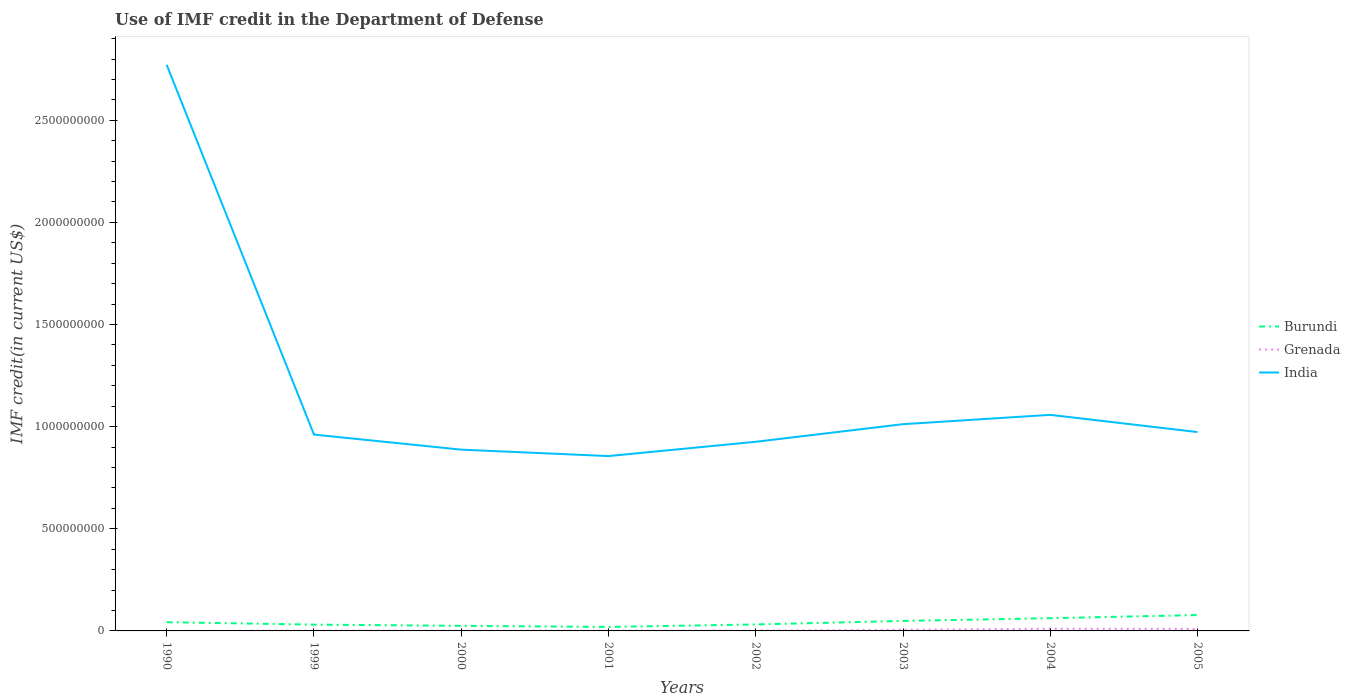Is the number of lines equal to the number of legend labels?
Keep it short and to the point. Yes. Across all years, what is the maximum IMF credit in the Department of Defense in Burundi?
Provide a short and direct response. 1.96e+07. What is the total IMF credit in the Department of Defense in Grenada in the graph?
Provide a succinct answer. -9.50e+04. What is the difference between the highest and the second highest IMF credit in the Department of Defense in Grenada?
Your answer should be very brief. 1.05e+07. What is the difference between the highest and the lowest IMF credit in the Department of Defense in Burundi?
Keep it short and to the point. 4. What is the difference between two consecutive major ticks on the Y-axis?
Your answer should be very brief. 5.00e+08. Does the graph contain grids?
Your answer should be very brief. No. How are the legend labels stacked?
Ensure brevity in your answer.  Vertical. What is the title of the graph?
Your answer should be compact. Use of IMF credit in the Department of Defense. What is the label or title of the X-axis?
Give a very brief answer. Years. What is the label or title of the Y-axis?
Give a very brief answer. IMF credit(in current US$). What is the IMF credit(in current US$) of Burundi in 1990?
Provide a succinct answer. 4.26e+07. What is the IMF credit(in current US$) of Grenada in 1990?
Offer a terse response. 1.10e+04. What is the IMF credit(in current US$) in India in 1990?
Your answer should be very brief. 2.77e+09. What is the IMF credit(in current US$) in Burundi in 1999?
Your answer should be compact. 3.09e+07. What is the IMF credit(in current US$) of Grenada in 1999?
Offer a very short reply. 1.28e+06. What is the IMF credit(in current US$) in India in 1999?
Your answer should be compact. 9.61e+08. What is the IMF credit(in current US$) of Burundi in 2000?
Keep it short and to the point. 2.48e+07. What is the IMF credit(in current US$) of Grenada in 2000?
Your answer should be very brief. 1.21e+06. What is the IMF credit(in current US$) of India in 2000?
Provide a succinct answer. 8.88e+08. What is the IMF credit(in current US$) in Burundi in 2001?
Give a very brief answer. 1.96e+07. What is the IMF credit(in current US$) in Grenada in 2001?
Provide a succinct answer. 1.17e+06. What is the IMF credit(in current US$) in India in 2001?
Ensure brevity in your answer.  8.56e+08. What is the IMF credit(in current US$) in Burundi in 2002?
Keep it short and to the point. 3.17e+07. What is the IMF credit(in current US$) of Grenada in 2002?
Ensure brevity in your answer.  1.26e+06. What is the IMF credit(in current US$) of India in 2002?
Ensure brevity in your answer.  9.26e+08. What is the IMF credit(in current US$) of Burundi in 2003?
Offer a very short reply. 4.90e+07. What is the IMF credit(in current US$) in Grenada in 2003?
Provide a succinct answer. 5.74e+06. What is the IMF credit(in current US$) of India in 2003?
Provide a short and direct response. 1.01e+09. What is the IMF credit(in current US$) of Burundi in 2004?
Your response must be concise. 6.23e+07. What is the IMF credit(in current US$) in Grenada in 2004?
Make the answer very short. 1.05e+07. What is the IMF credit(in current US$) of India in 2004?
Keep it short and to the point. 1.06e+09. What is the IMF credit(in current US$) of Burundi in 2005?
Provide a succinct answer. 7.77e+07. What is the IMF credit(in current US$) in Grenada in 2005?
Provide a succinct answer. 9.70e+06. What is the IMF credit(in current US$) of India in 2005?
Your answer should be very brief. 9.74e+08. Across all years, what is the maximum IMF credit(in current US$) in Burundi?
Your answer should be very brief. 7.77e+07. Across all years, what is the maximum IMF credit(in current US$) of Grenada?
Give a very brief answer. 1.05e+07. Across all years, what is the maximum IMF credit(in current US$) in India?
Provide a succinct answer. 2.77e+09. Across all years, what is the minimum IMF credit(in current US$) of Burundi?
Make the answer very short. 1.96e+07. Across all years, what is the minimum IMF credit(in current US$) of Grenada?
Offer a very short reply. 1.10e+04. Across all years, what is the minimum IMF credit(in current US$) of India?
Provide a short and direct response. 8.56e+08. What is the total IMF credit(in current US$) in Burundi in the graph?
Your answer should be compact. 3.39e+08. What is the total IMF credit(in current US$) of Grenada in the graph?
Offer a terse response. 3.09e+07. What is the total IMF credit(in current US$) of India in the graph?
Offer a very short reply. 9.45e+09. What is the difference between the IMF credit(in current US$) in Burundi in 1990 and that in 1999?
Give a very brief answer. 1.17e+07. What is the difference between the IMF credit(in current US$) in Grenada in 1990 and that in 1999?
Make the answer very short. -1.26e+06. What is the difference between the IMF credit(in current US$) of India in 1990 and that in 1999?
Your answer should be very brief. 1.81e+09. What is the difference between the IMF credit(in current US$) in Burundi in 1990 and that in 2000?
Offer a very short reply. 1.78e+07. What is the difference between the IMF credit(in current US$) in Grenada in 1990 and that in 2000?
Your answer should be very brief. -1.20e+06. What is the difference between the IMF credit(in current US$) of India in 1990 and that in 2000?
Provide a succinct answer. 1.88e+09. What is the difference between the IMF credit(in current US$) in Burundi in 1990 and that in 2001?
Provide a succinct answer. 2.30e+07. What is the difference between the IMF credit(in current US$) of Grenada in 1990 and that in 2001?
Give a very brief answer. -1.16e+06. What is the difference between the IMF credit(in current US$) in India in 1990 and that in 2001?
Make the answer very short. 1.92e+09. What is the difference between the IMF credit(in current US$) of Burundi in 1990 and that in 2002?
Provide a succinct answer. 1.09e+07. What is the difference between the IMF credit(in current US$) of Grenada in 1990 and that in 2002?
Your answer should be very brief. -1.25e+06. What is the difference between the IMF credit(in current US$) of India in 1990 and that in 2002?
Offer a terse response. 1.85e+09. What is the difference between the IMF credit(in current US$) of Burundi in 1990 and that in 2003?
Offer a very short reply. -6.33e+06. What is the difference between the IMF credit(in current US$) of Grenada in 1990 and that in 2003?
Your answer should be very brief. -5.72e+06. What is the difference between the IMF credit(in current US$) in India in 1990 and that in 2003?
Ensure brevity in your answer.  1.76e+09. What is the difference between the IMF credit(in current US$) in Burundi in 1990 and that in 2004?
Offer a terse response. -1.96e+07. What is the difference between the IMF credit(in current US$) in Grenada in 1990 and that in 2004?
Provide a short and direct response. -1.05e+07. What is the difference between the IMF credit(in current US$) of India in 1990 and that in 2004?
Ensure brevity in your answer.  1.71e+09. What is the difference between the IMF credit(in current US$) in Burundi in 1990 and that in 2005?
Your response must be concise. -3.51e+07. What is the difference between the IMF credit(in current US$) in Grenada in 1990 and that in 2005?
Make the answer very short. -9.69e+06. What is the difference between the IMF credit(in current US$) in India in 1990 and that in 2005?
Make the answer very short. 1.80e+09. What is the difference between the IMF credit(in current US$) of Burundi in 1999 and that in 2000?
Offer a very short reply. 6.05e+06. What is the difference between the IMF credit(in current US$) of Grenada in 1999 and that in 2000?
Offer a terse response. 6.40e+04. What is the difference between the IMF credit(in current US$) in India in 1999 and that in 2000?
Offer a very short reply. 7.38e+07. What is the difference between the IMF credit(in current US$) in Burundi in 1999 and that in 2001?
Give a very brief answer. 1.13e+07. What is the difference between the IMF credit(in current US$) in Grenada in 1999 and that in 2001?
Keep it short and to the point. 1.07e+05. What is the difference between the IMF credit(in current US$) in India in 1999 and that in 2001?
Provide a short and direct response. 1.05e+08. What is the difference between the IMF credit(in current US$) in Burundi in 1999 and that in 2002?
Offer a terse response. -8.04e+05. What is the difference between the IMF credit(in current US$) of Grenada in 1999 and that in 2002?
Provide a succinct answer. 1.20e+04. What is the difference between the IMF credit(in current US$) in India in 1999 and that in 2002?
Your answer should be compact. 3.53e+07. What is the difference between the IMF credit(in current US$) of Burundi in 1999 and that in 2003?
Offer a terse response. -1.81e+07. What is the difference between the IMF credit(in current US$) in Grenada in 1999 and that in 2003?
Keep it short and to the point. -4.46e+06. What is the difference between the IMF credit(in current US$) of India in 1999 and that in 2003?
Keep it short and to the point. -5.09e+07. What is the difference between the IMF credit(in current US$) of Burundi in 1999 and that in 2004?
Provide a short and direct response. -3.14e+07. What is the difference between the IMF credit(in current US$) of Grenada in 1999 and that in 2004?
Keep it short and to the point. -9.26e+06. What is the difference between the IMF credit(in current US$) in India in 1999 and that in 2004?
Provide a succinct answer. -9.65e+07. What is the difference between the IMF credit(in current US$) in Burundi in 1999 and that in 2005?
Provide a short and direct response. -4.68e+07. What is the difference between the IMF credit(in current US$) in Grenada in 1999 and that in 2005?
Keep it short and to the point. -8.42e+06. What is the difference between the IMF credit(in current US$) of India in 1999 and that in 2005?
Offer a terse response. -1.22e+07. What is the difference between the IMF credit(in current US$) in Burundi in 2000 and that in 2001?
Provide a short and direct response. 5.21e+06. What is the difference between the IMF credit(in current US$) in Grenada in 2000 and that in 2001?
Provide a short and direct response. 4.30e+04. What is the difference between the IMF credit(in current US$) of India in 2000 and that in 2001?
Give a very brief answer. 3.15e+07. What is the difference between the IMF credit(in current US$) in Burundi in 2000 and that in 2002?
Keep it short and to the point. -6.86e+06. What is the difference between the IMF credit(in current US$) of Grenada in 2000 and that in 2002?
Your response must be concise. -5.20e+04. What is the difference between the IMF credit(in current US$) in India in 2000 and that in 2002?
Make the answer very short. -3.86e+07. What is the difference between the IMF credit(in current US$) of Burundi in 2000 and that in 2003?
Ensure brevity in your answer.  -2.41e+07. What is the difference between the IMF credit(in current US$) of Grenada in 2000 and that in 2003?
Give a very brief answer. -4.52e+06. What is the difference between the IMF credit(in current US$) in India in 2000 and that in 2003?
Make the answer very short. -1.25e+08. What is the difference between the IMF credit(in current US$) of Burundi in 2000 and that in 2004?
Keep it short and to the point. -3.74e+07. What is the difference between the IMF credit(in current US$) in Grenada in 2000 and that in 2004?
Keep it short and to the point. -9.32e+06. What is the difference between the IMF credit(in current US$) in India in 2000 and that in 2004?
Ensure brevity in your answer.  -1.70e+08. What is the difference between the IMF credit(in current US$) of Burundi in 2000 and that in 2005?
Offer a terse response. -5.29e+07. What is the difference between the IMF credit(in current US$) in Grenada in 2000 and that in 2005?
Make the answer very short. -8.48e+06. What is the difference between the IMF credit(in current US$) of India in 2000 and that in 2005?
Keep it short and to the point. -8.61e+07. What is the difference between the IMF credit(in current US$) in Burundi in 2001 and that in 2002?
Provide a succinct answer. -1.21e+07. What is the difference between the IMF credit(in current US$) of Grenada in 2001 and that in 2002?
Your answer should be compact. -9.50e+04. What is the difference between the IMF credit(in current US$) in India in 2001 and that in 2002?
Keep it short and to the point. -7.00e+07. What is the difference between the IMF credit(in current US$) in Burundi in 2001 and that in 2003?
Offer a very short reply. -2.93e+07. What is the difference between the IMF credit(in current US$) of Grenada in 2001 and that in 2003?
Give a very brief answer. -4.57e+06. What is the difference between the IMF credit(in current US$) of India in 2001 and that in 2003?
Ensure brevity in your answer.  -1.56e+08. What is the difference between the IMF credit(in current US$) in Burundi in 2001 and that in 2004?
Make the answer very short. -4.26e+07. What is the difference between the IMF credit(in current US$) of Grenada in 2001 and that in 2004?
Your response must be concise. -9.37e+06. What is the difference between the IMF credit(in current US$) of India in 2001 and that in 2004?
Your answer should be compact. -2.02e+08. What is the difference between the IMF credit(in current US$) of Burundi in 2001 and that in 2005?
Your answer should be very brief. -5.81e+07. What is the difference between the IMF credit(in current US$) of Grenada in 2001 and that in 2005?
Your response must be concise. -8.53e+06. What is the difference between the IMF credit(in current US$) in India in 2001 and that in 2005?
Your response must be concise. -1.18e+08. What is the difference between the IMF credit(in current US$) of Burundi in 2002 and that in 2003?
Keep it short and to the point. -1.73e+07. What is the difference between the IMF credit(in current US$) of Grenada in 2002 and that in 2003?
Offer a terse response. -4.47e+06. What is the difference between the IMF credit(in current US$) of India in 2002 and that in 2003?
Offer a terse response. -8.61e+07. What is the difference between the IMF credit(in current US$) of Burundi in 2002 and that in 2004?
Your answer should be compact. -3.06e+07. What is the difference between the IMF credit(in current US$) in Grenada in 2002 and that in 2004?
Your answer should be compact. -9.27e+06. What is the difference between the IMF credit(in current US$) of India in 2002 and that in 2004?
Keep it short and to the point. -1.32e+08. What is the difference between the IMF credit(in current US$) of Burundi in 2002 and that in 2005?
Offer a very short reply. -4.60e+07. What is the difference between the IMF credit(in current US$) in Grenada in 2002 and that in 2005?
Your answer should be very brief. -8.43e+06. What is the difference between the IMF credit(in current US$) of India in 2002 and that in 2005?
Your answer should be very brief. -4.75e+07. What is the difference between the IMF credit(in current US$) in Burundi in 2003 and that in 2004?
Give a very brief answer. -1.33e+07. What is the difference between the IMF credit(in current US$) in Grenada in 2003 and that in 2004?
Your answer should be compact. -4.80e+06. What is the difference between the IMF credit(in current US$) in India in 2003 and that in 2004?
Your answer should be very brief. -4.57e+07. What is the difference between the IMF credit(in current US$) in Burundi in 2003 and that in 2005?
Give a very brief answer. -2.88e+07. What is the difference between the IMF credit(in current US$) in Grenada in 2003 and that in 2005?
Offer a terse response. -3.96e+06. What is the difference between the IMF credit(in current US$) of India in 2003 and that in 2005?
Keep it short and to the point. 3.86e+07. What is the difference between the IMF credit(in current US$) of Burundi in 2004 and that in 2005?
Provide a short and direct response. -1.55e+07. What is the difference between the IMF credit(in current US$) of Grenada in 2004 and that in 2005?
Your answer should be very brief. 8.40e+05. What is the difference between the IMF credit(in current US$) in India in 2004 and that in 2005?
Ensure brevity in your answer.  8.43e+07. What is the difference between the IMF credit(in current US$) of Burundi in 1990 and the IMF credit(in current US$) of Grenada in 1999?
Your answer should be very brief. 4.13e+07. What is the difference between the IMF credit(in current US$) of Burundi in 1990 and the IMF credit(in current US$) of India in 1999?
Keep it short and to the point. -9.19e+08. What is the difference between the IMF credit(in current US$) of Grenada in 1990 and the IMF credit(in current US$) of India in 1999?
Keep it short and to the point. -9.61e+08. What is the difference between the IMF credit(in current US$) in Burundi in 1990 and the IMF credit(in current US$) in Grenada in 2000?
Give a very brief answer. 4.14e+07. What is the difference between the IMF credit(in current US$) in Burundi in 1990 and the IMF credit(in current US$) in India in 2000?
Your answer should be compact. -8.45e+08. What is the difference between the IMF credit(in current US$) in Grenada in 1990 and the IMF credit(in current US$) in India in 2000?
Your answer should be compact. -8.87e+08. What is the difference between the IMF credit(in current US$) in Burundi in 1990 and the IMF credit(in current US$) in Grenada in 2001?
Keep it short and to the point. 4.15e+07. What is the difference between the IMF credit(in current US$) in Burundi in 1990 and the IMF credit(in current US$) in India in 2001?
Your answer should be compact. -8.13e+08. What is the difference between the IMF credit(in current US$) of Grenada in 1990 and the IMF credit(in current US$) of India in 2001?
Ensure brevity in your answer.  -8.56e+08. What is the difference between the IMF credit(in current US$) in Burundi in 1990 and the IMF credit(in current US$) in Grenada in 2002?
Provide a succinct answer. 4.14e+07. What is the difference between the IMF credit(in current US$) of Burundi in 1990 and the IMF credit(in current US$) of India in 2002?
Your answer should be compact. -8.83e+08. What is the difference between the IMF credit(in current US$) of Grenada in 1990 and the IMF credit(in current US$) of India in 2002?
Your response must be concise. -9.26e+08. What is the difference between the IMF credit(in current US$) of Burundi in 1990 and the IMF credit(in current US$) of Grenada in 2003?
Make the answer very short. 3.69e+07. What is the difference between the IMF credit(in current US$) in Burundi in 1990 and the IMF credit(in current US$) in India in 2003?
Your response must be concise. -9.70e+08. What is the difference between the IMF credit(in current US$) in Grenada in 1990 and the IMF credit(in current US$) in India in 2003?
Provide a succinct answer. -1.01e+09. What is the difference between the IMF credit(in current US$) of Burundi in 1990 and the IMF credit(in current US$) of Grenada in 2004?
Provide a short and direct response. 3.21e+07. What is the difference between the IMF credit(in current US$) of Burundi in 1990 and the IMF credit(in current US$) of India in 2004?
Ensure brevity in your answer.  -1.02e+09. What is the difference between the IMF credit(in current US$) in Grenada in 1990 and the IMF credit(in current US$) in India in 2004?
Provide a short and direct response. -1.06e+09. What is the difference between the IMF credit(in current US$) of Burundi in 1990 and the IMF credit(in current US$) of Grenada in 2005?
Your answer should be compact. 3.29e+07. What is the difference between the IMF credit(in current US$) of Burundi in 1990 and the IMF credit(in current US$) of India in 2005?
Make the answer very short. -9.31e+08. What is the difference between the IMF credit(in current US$) of Grenada in 1990 and the IMF credit(in current US$) of India in 2005?
Your response must be concise. -9.74e+08. What is the difference between the IMF credit(in current US$) of Burundi in 1999 and the IMF credit(in current US$) of Grenada in 2000?
Your answer should be compact. 2.97e+07. What is the difference between the IMF credit(in current US$) of Burundi in 1999 and the IMF credit(in current US$) of India in 2000?
Your answer should be compact. -8.57e+08. What is the difference between the IMF credit(in current US$) in Grenada in 1999 and the IMF credit(in current US$) in India in 2000?
Give a very brief answer. -8.86e+08. What is the difference between the IMF credit(in current US$) of Burundi in 1999 and the IMF credit(in current US$) of Grenada in 2001?
Your answer should be compact. 2.97e+07. What is the difference between the IMF credit(in current US$) in Burundi in 1999 and the IMF credit(in current US$) in India in 2001?
Offer a very short reply. -8.25e+08. What is the difference between the IMF credit(in current US$) of Grenada in 1999 and the IMF credit(in current US$) of India in 2001?
Provide a succinct answer. -8.55e+08. What is the difference between the IMF credit(in current US$) in Burundi in 1999 and the IMF credit(in current US$) in Grenada in 2002?
Your answer should be very brief. 2.96e+07. What is the difference between the IMF credit(in current US$) in Burundi in 1999 and the IMF credit(in current US$) in India in 2002?
Your answer should be compact. -8.95e+08. What is the difference between the IMF credit(in current US$) in Grenada in 1999 and the IMF credit(in current US$) in India in 2002?
Make the answer very short. -9.25e+08. What is the difference between the IMF credit(in current US$) in Burundi in 1999 and the IMF credit(in current US$) in Grenada in 2003?
Offer a terse response. 2.52e+07. What is the difference between the IMF credit(in current US$) in Burundi in 1999 and the IMF credit(in current US$) in India in 2003?
Give a very brief answer. -9.81e+08. What is the difference between the IMF credit(in current US$) in Grenada in 1999 and the IMF credit(in current US$) in India in 2003?
Offer a terse response. -1.01e+09. What is the difference between the IMF credit(in current US$) of Burundi in 1999 and the IMF credit(in current US$) of Grenada in 2004?
Provide a short and direct response. 2.04e+07. What is the difference between the IMF credit(in current US$) in Burundi in 1999 and the IMF credit(in current US$) in India in 2004?
Make the answer very short. -1.03e+09. What is the difference between the IMF credit(in current US$) of Grenada in 1999 and the IMF credit(in current US$) of India in 2004?
Provide a succinct answer. -1.06e+09. What is the difference between the IMF credit(in current US$) of Burundi in 1999 and the IMF credit(in current US$) of Grenada in 2005?
Give a very brief answer. 2.12e+07. What is the difference between the IMF credit(in current US$) of Burundi in 1999 and the IMF credit(in current US$) of India in 2005?
Keep it short and to the point. -9.43e+08. What is the difference between the IMF credit(in current US$) in Grenada in 1999 and the IMF credit(in current US$) in India in 2005?
Keep it short and to the point. -9.72e+08. What is the difference between the IMF credit(in current US$) in Burundi in 2000 and the IMF credit(in current US$) in Grenada in 2001?
Provide a succinct answer. 2.37e+07. What is the difference between the IMF credit(in current US$) of Burundi in 2000 and the IMF credit(in current US$) of India in 2001?
Your answer should be compact. -8.31e+08. What is the difference between the IMF credit(in current US$) in Grenada in 2000 and the IMF credit(in current US$) in India in 2001?
Give a very brief answer. -8.55e+08. What is the difference between the IMF credit(in current US$) of Burundi in 2000 and the IMF credit(in current US$) of Grenada in 2002?
Offer a terse response. 2.36e+07. What is the difference between the IMF credit(in current US$) in Burundi in 2000 and the IMF credit(in current US$) in India in 2002?
Give a very brief answer. -9.01e+08. What is the difference between the IMF credit(in current US$) in Grenada in 2000 and the IMF credit(in current US$) in India in 2002?
Provide a short and direct response. -9.25e+08. What is the difference between the IMF credit(in current US$) in Burundi in 2000 and the IMF credit(in current US$) in Grenada in 2003?
Give a very brief answer. 1.91e+07. What is the difference between the IMF credit(in current US$) of Burundi in 2000 and the IMF credit(in current US$) of India in 2003?
Your answer should be very brief. -9.87e+08. What is the difference between the IMF credit(in current US$) in Grenada in 2000 and the IMF credit(in current US$) in India in 2003?
Keep it short and to the point. -1.01e+09. What is the difference between the IMF credit(in current US$) in Burundi in 2000 and the IMF credit(in current US$) in Grenada in 2004?
Offer a very short reply. 1.43e+07. What is the difference between the IMF credit(in current US$) in Burundi in 2000 and the IMF credit(in current US$) in India in 2004?
Your answer should be very brief. -1.03e+09. What is the difference between the IMF credit(in current US$) of Grenada in 2000 and the IMF credit(in current US$) of India in 2004?
Your response must be concise. -1.06e+09. What is the difference between the IMF credit(in current US$) in Burundi in 2000 and the IMF credit(in current US$) in Grenada in 2005?
Give a very brief answer. 1.52e+07. What is the difference between the IMF credit(in current US$) of Burundi in 2000 and the IMF credit(in current US$) of India in 2005?
Your response must be concise. -9.49e+08. What is the difference between the IMF credit(in current US$) in Grenada in 2000 and the IMF credit(in current US$) in India in 2005?
Your response must be concise. -9.72e+08. What is the difference between the IMF credit(in current US$) in Burundi in 2001 and the IMF credit(in current US$) in Grenada in 2002?
Your answer should be very brief. 1.84e+07. What is the difference between the IMF credit(in current US$) of Burundi in 2001 and the IMF credit(in current US$) of India in 2002?
Make the answer very short. -9.06e+08. What is the difference between the IMF credit(in current US$) of Grenada in 2001 and the IMF credit(in current US$) of India in 2002?
Give a very brief answer. -9.25e+08. What is the difference between the IMF credit(in current US$) in Burundi in 2001 and the IMF credit(in current US$) in Grenada in 2003?
Provide a short and direct response. 1.39e+07. What is the difference between the IMF credit(in current US$) in Burundi in 2001 and the IMF credit(in current US$) in India in 2003?
Your answer should be compact. -9.93e+08. What is the difference between the IMF credit(in current US$) of Grenada in 2001 and the IMF credit(in current US$) of India in 2003?
Provide a short and direct response. -1.01e+09. What is the difference between the IMF credit(in current US$) of Burundi in 2001 and the IMF credit(in current US$) of Grenada in 2004?
Ensure brevity in your answer.  9.11e+06. What is the difference between the IMF credit(in current US$) in Burundi in 2001 and the IMF credit(in current US$) in India in 2004?
Make the answer very short. -1.04e+09. What is the difference between the IMF credit(in current US$) in Grenada in 2001 and the IMF credit(in current US$) in India in 2004?
Keep it short and to the point. -1.06e+09. What is the difference between the IMF credit(in current US$) in Burundi in 2001 and the IMF credit(in current US$) in Grenada in 2005?
Give a very brief answer. 9.95e+06. What is the difference between the IMF credit(in current US$) of Burundi in 2001 and the IMF credit(in current US$) of India in 2005?
Keep it short and to the point. -9.54e+08. What is the difference between the IMF credit(in current US$) of Grenada in 2001 and the IMF credit(in current US$) of India in 2005?
Your response must be concise. -9.72e+08. What is the difference between the IMF credit(in current US$) of Burundi in 2002 and the IMF credit(in current US$) of Grenada in 2003?
Your answer should be very brief. 2.60e+07. What is the difference between the IMF credit(in current US$) in Burundi in 2002 and the IMF credit(in current US$) in India in 2003?
Your response must be concise. -9.80e+08. What is the difference between the IMF credit(in current US$) of Grenada in 2002 and the IMF credit(in current US$) of India in 2003?
Ensure brevity in your answer.  -1.01e+09. What is the difference between the IMF credit(in current US$) in Burundi in 2002 and the IMF credit(in current US$) in Grenada in 2004?
Your answer should be compact. 2.12e+07. What is the difference between the IMF credit(in current US$) of Burundi in 2002 and the IMF credit(in current US$) of India in 2004?
Ensure brevity in your answer.  -1.03e+09. What is the difference between the IMF credit(in current US$) in Grenada in 2002 and the IMF credit(in current US$) in India in 2004?
Give a very brief answer. -1.06e+09. What is the difference between the IMF credit(in current US$) of Burundi in 2002 and the IMF credit(in current US$) of Grenada in 2005?
Offer a very short reply. 2.20e+07. What is the difference between the IMF credit(in current US$) in Burundi in 2002 and the IMF credit(in current US$) in India in 2005?
Offer a terse response. -9.42e+08. What is the difference between the IMF credit(in current US$) of Grenada in 2002 and the IMF credit(in current US$) of India in 2005?
Your answer should be compact. -9.72e+08. What is the difference between the IMF credit(in current US$) of Burundi in 2003 and the IMF credit(in current US$) of Grenada in 2004?
Offer a very short reply. 3.84e+07. What is the difference between the IMF credit(in current US$) of Burundi in 2003 and the IMF credit(in current US$) of India in 2004?
Ensure brevity in your answer.  -1.01e+09. What is the difference between the IMF credit(in current US$) in Grenada in 2003 and the IMF credit(in current US$) in India in 2004?
Offer a very short reply. -1.05e+09. What is the difference between the IMF credit(in current US$) of Burundi in 2003 and the IMF credit(in current US$) of Grenada in 2005?
Offer a very short reply. 3.93e+07. What is the difference between the IMF credit(in current US$) of Burundi in 2003 and the IMF credit(in current US$) of India in 2005?
Your response must be concise. -9.25e+08. What is the difference between the IMF credit(in current US$) in Grenada in 2003 and the IMF credit(in current US$) in India in 2005?
Give a very brief answer. -9.68e+08. What is the difference between the IMF credit(in current US$) in Burundi in 2004 and the IMF credit(in current US$) in Grenada in 2005?
Provide a succinct answer. 5.26e+07. What is the difference between the IMF credit(in current US$) of Burundi in 2004 and the IMF credit(in current US$) of India in 2005?
Provide a short and direct response. -9.11e+08. What is the difference between the IMF credit(in current US$) of Grenada in 2004 and the IMF credit(in current US$) of India in 2005?
Offer a terse response. -9.63e+08. What is the average IMF credit(in current US$) in Burundi per year?
Offer a very short reply. 4.23e+07. What is the average IMF credit(in current US$) of Grenada per year?
Make the answer very short. 3.86e+06. What is the average IMF credit(in current US$) in India per year?
Ensure brevity in your answer.  1.18e+09. In the year 1990, what is the difference between the IMF credit(in current US$) in Burundi and IMF credit(in current US$) in Grenada?
Ensure brevity in your answer.  4.26e+07. In the year 1990, what is the difference between the IMF credit(in current US$) of Burundi and IMF credit(in current US$) of India?
Your answer should be very brief. -2.73e+09. In the year 1990, what is the difference between the IMF credit(in current US$) of Grenada and IMF credit(in current US$) of India?
Your response must be concise. -2.77e+09. In the year 1999, what is the difference between the IMF credit(in current US$) of Burundi and IMF credit(in current US$) of Grenada?
Your response must be concise. 2.96e+07. In the year 1999, what is the difference between the IMF credit(in current US$) in Burundi and IMF credit(in current US$) in India?
Your answer should be compact. -9.30e+08. In the year 1999, what is the difference between the IMF credit(in current US$) of Grenada and IMF credit(in current US$) of India?
Provide a short and direct response. -9.60e+08. In the year 2000, what is the difference between the IMF credit(in current US$) of Burundi and IMF credit(in current US$) of Grenada?
Keep it short and to the point. 2.36e+07. In the year 2000, what is the difference between the IMF credit(in current US$) of Burundi and IMF credit(in current US$) of India?
Give a very brief answer. -8.63e+08. In the year 2000, what is the difference between the IMF credit(in current US$) in Grenada and IMF credit(in current US$) in India?
Provide a succinct answer. -8.86e+08. In the year 2001, what is the difference between the IMF credit(in current US$) of Burundi and IMF credit(in current US$) of Grenada?
Keep it short and to the point. 1.85e+07. In the year 2001, what is the difference between the IMF credit(in current US$) in Burundi and IMF credit(in current US$) in India?
Your answer should be compact. -8.36e+08. In the year 2001, what is the difference between the IMF credit(in current US$) of Grenada and IMF credit(in current US$) of India?
Offer a very short reply. -8.55e+08. In the year 2002, what is the difference between the IMF credit(in current US$) in Burundi and IMF credit(in current US$) in Grenada?
Your response must be concise. 3.04e+07. In the year 2002, what is the difference between the IMF credit(in current US$) in Burundi and IMF credit(in current US$) in India?
Offer a terse response. -8.94e+08. In the year 2002, what is the difference between the IMF credit(in current US$) of Grenada and IMF credit(in current US$) of India?
Offer a terse response. -9.25e+08. In the year 2003, what is the difference between the IMF credit(in current US$) in Burundi and IMF credit(in current US$) in Grenada?
Your response must be concise. 4.32e+07. In the year 2003, what is the difference between the IMF credit(in current US$) of Burundi and IMF credit(in current US$) of India?
Offer a very short reply. -9.63e+08. In the year 2003, what is the difference between the IMF credit(in current US$) of Grenada and IMF credit(in current US$) of India?
Offer a terse response. -1.01e+09. In the year 2004, what is the difference between the IMF credit(in current US$) of Burundi and IMF credit(in current US$) of Grenada?
Ensure brevity in your answer.  5.17e+07. In the year 2004, what is the difference between the IMF credit(in current US$) of Burundi and IMF credit(in current US$) of India?
Offer a terse response. -9.96e+08. In the year 2004, what is the difference between the IMF credit(in current US$) of Grenada and IMF credit(in current US$) of India?
Ensure brevity in your answer.  -1.05e+09. In the year 2005, what is the difference between the IMF credit(in current US$) of Burundi and IMF credit(in current US$) of Grenada?
Provide a succinct answer. 6.81e+07. In the year 2005, what is the difference between the IMF credit(in current US$) in Burundi and IMF credit(in current US$) in India?
Provide a short and direct response. -8.96e+08. In the year 2005, what is the difference between the IMF credit(in current US$) in Grenada and IMF credit(in current US$) in India?
Keep it short and to the point. -9.64e+08. What is the ratio of the IMF credit(in current US$) of Burundi in 1990 to that in 1999?
Offer a terse response. 1.38. What is the ratio of the IMF credit(in current US$) in Grenada in 1990 to that in 1999?
Provide a succinct answer. 0.01. What is the ratio of the IMF credit(in current US$) of India in 1990 to that in 1999?
Ensure brevity in your answer.  2.88. What is the ratio of the IMF credit(in current US$) of Burundi in 1990 to that in 2000?
Provide a short and direct response. 1.72. What is the ratio of the IMF credit(in current US$) in Grenada in 1990 to that in 2000?
Offer a terse response. 0.01. What is the ratio of the IMF credit(in current US$) in India in 1990 to that in 2000?
Your answer should be very brief. 3.12. What is the ratio of the IMF credit(in current US$) in Burundi in 1990 to that in 2001?
Ensure brevity in your answer.  2.17. What is the ratio of the IMF credit(in current US$) in Grenada in 1990 to that in 2001?
Provide a short and direct response. 0.01. What is the ratio of the IMF credit(in current US$) in India in 1990 to that in 2001?
Keep it short and to the point. 3.24. What is the ratio of the IMF credit(in current US$) in Burundi in 1990 to that in 2002?
Provide a short and direct response. 1.34. What is the ratio of the IMF credit(in current US$) in Grenada in 1990 to that in 2002?
Make the answer very short. 0.01. What is the ratio of the IMF credit(in current US$) in India in 1990 to that in 2002?
Provide a succinct answer. 2.99. What is the ratio of the IMF credit(in current US$) of Burundi in 1990 to that in 2003?
Provide a succinct answer. 0.87. What is the ratio of the IMF credit(in current US$) in Grenada in 1990 to that in 2003?
Give a very brief answer. 0. What is the ratio of the IMF credit(in current US$) in India in 1990 to that in 2003?
Your response must be concise. 2.74. What is the ratio of the IMF credit(in current US$) in Burundi in 1990 to that in 2004?
Your answer should be compact. 0.68. What is the ratio of the IMF credit(in current US$) of Grenada in 1990 to that in 2004?
Provide a succinct answer. 0. What is the ratio of the IMF credit(in current US$) of India in 1990 to that in 2004?
Keep it short and to the point. 2.62. What is the ratio of the IMF credit(in current US$) in Burundi in 1990 to that in 2005?
Your answer should be compact. 0.55. What is the ratio of the IMF credit(in current US$) in Grenada in 1990 to that in 2005?
Ensure brevity in your answer.  0. What is the ratio of the IMF credit(in current US$) in India in 1990 to that in 2005?
Your answer should be compact. 2.85. What is the ratio of the IMF credit(in current US$) of Burundi in 1999 to that in 2000?
Offer a terse response. 1.24. What is the ratio of the IMF credit(in current US$) of Grenada in 1999 to that in 2000?
Offer a terse response. 1.05. What is the ratio of the IMF credit(in current US$) in India in 1999 to that in 2000?
Offer a terse response. 1.08. What is the ratio of the IMF credit(in current US$) in Burundi in 1999 to that in 2001?
Offer a terse response. 1.57. What is the ratio of the IMF credit(in current US$) in Grenada in 1999 to that in 2001?
Offer a terse response. 1.09. What is the ratio of the IMF credit(in current US$) in India in 1999 to that in 2001?
Keep it short and to the point. 1.12. What is the ratio of the IMF credit(in current US$) of Burundi in 1999 to that in 2002?
Give a very brief answer. 0.97. What is the ratio of the IMF credit(in current US$) of Grenada in 1999 to that in 2002?
Give a very brief answer. 1.01. What is the ratio of the IMF credit(in current US$) in India in 1999 to that in 2002?
Your answer should be very brief. 1.04. What is the ratio of the IMF credit(in current US$) in Burundi in 1999 to that in 2003?
Provide a succinct answer. 0.63. What is the ratio of the IMF credit(in current US$) of Grenada in 1999 to that in 2003?
Ensure brevity in your answer.  0.22. What is the ratio of the IMF credit(in current US$) of India in 1999 to that in 2003?
Offer a very short reply. 0.95. What is the ratio of the IMF credit(in current US$) of Burundi in 1999 to that in 2004?
Offer a very short reply. 0.5. What is the ratio of the IMF credit(in current US$) of Grenada in 1999 to that in 2004?
Your response must be concise. 0.12. What is the ratio of the IMF credit(in current US$) in India in 1999 to that in 2004?
Provide a short and direct response. 0.91. What is the ratio of the IMF credit(in current US$) of Burundi in 1999 to that in 2005?
Your answer should be compact. 0.4. What is the ratio of the IMF credit(in current US$) of Grenada in 1999 to that in 2005?
Offer a terse response. 0.13. What is the ratio of the IMF credit(in current US$) of India in 1999 to that in 2005?
Keep it short and to the point. 0.99. What is the ratio of the IMF credit(in current US$) in Burundi in 2000 to that in 2001?
Give a very brief answer. 1.26. What is the ratio of the IMF credit(in current US$) of Grenada in 2000 to that in 2001?
Offer a terse response. 1.04. What is the ratio of the IMF credit(in current US$) in India in 2000 to that in 2001?
Your response must be concise. 1.04. What is the ratio of the IMF credit(in current US$) in Burundi in 2000 to that in 2002?
Keep it short and to the point. 0.78. What is the ratio of the IMF credit(in current US$) of Grenada in 2000 to that in 2002?
Offer a terse response. 0.96. What is the ratio of the IMF credit(in current US$) of India in 2000 to that in 2002?
Give a very brief answer. 0.96. What is the ratio of the IMF credit(in current US$) in Burundi in 2000 to that in 2003?
Offer a terse response. 0.51. What is the ratio of the IMF credit(in current US$) of Grenada in 2000 to that in 2003?
Keep it short and to the point. 0.21. What is the ratio of the IMF credit(in current US$) in India in 2000 to that in 2003?
Make the answer very short. 0.88. What is the ratio of the IMF credit(in current US$) of Burundi in 2000 to that in 2004?
Your answer should be compact. 0.4. What is the ratio of the IMF credit(in current US$) of Grenada in 2000 to that in 2004?
Ensure brevity in your answer.  0.12. What is the ratio of the IMF credit(in current US$) of India in 2000 to that in 2004?
Ensure brevity in your answer.  0.84. What is the ratio of the IMF credit(in current US$) in Burundi in 2000 to that in 2005?
Give a very brief answer. 0.32. What is the ratio of the IMF credit(in current US$) of India in 2000 to that in 2005?
Make the answer very short. 0.91. What is the ratio of the IMF credit(in current US$) in Burundi in 2001 to that in 2002?
Give a very brief answer. 0.62. What is the ratio of the IMF credit(in current US$) in Grenada in 2001 to that in 2002?
Give a very brief answer. 0.92. What is the ratio of the IMF credit(in current US$) in India in 2001 to that in 2002?
Offer a terse response. 0.92. What is the ratio of the IMF credit(in current US$) in Burundi in 2001 to that in 2003?
Give a very brief answer. 0.4. What is the ratio of the IMF credit(in current US$) in Grenada in 2001 to that in 2003?
Keep it short and to the point. 0.2. What is the ratio of the IMF credit(in current US$) in India in 2001 to that in 2003?
Ensure brevity in your answer.  0.85. What is the ratio of the IMF credit(in current US$) of Burundi in 2001 to that in 2004?
Your answer should be very brief. 0.32. What is the ratio of the IMF credit(in current US$) of Grenada in 2001 to that in 2004?
Your answer should be very brief. 0.11. What is the ratio of the IMF credit(in current US$) of India in 2001 to that in 2004?
Your answer should be compact. 0.81. What is the ratio of the IMF credit(in current US$) of Burundi in 2001 to that in 2005?
Provide a succinct answer. 0.25. What is the ratio of the IMF credit(in current US$) of Grenada in 2001 to that in 2005?
Provide a short and direct response. 0.12. What is the ratio of the IMF credit(in current US$) in India in 2001 to that in 2005?
Give a very brief answer. 0.88. What is the ratio of the IMF credit(in current US$) of Burundi in 2002 to that in 2003?
Keep it short and to the point. 0.65. What is the ratio of the IMF credit(in current US$) in Grenada in 2002 to that in 2003?
Make the answer very short. 0.22. What is the ratio of the IMF credit(in current US$) in India in 2002 to that in 2003?
Provide a succinct answer. 0.91. What is the ratio of the IMF credit(in current US$) of Burundi in 2002 to that in 2004?
Provide a succinct answer. 0.51. What is the ratio of the IMF credit(in current US$) in Grenada in 2002 to that in 2004?
Keep it short and to the point. 0.12. What is the ratio of the IMF credit(in current US$) in India in 2002 to that in 2004?
Provide a succinct answer. 0.88. What is the ratio of the IMF credit(in current US$) of Burundi in 2002 to that in 2005?
Offer a very short reply. 0.41. What is the ratio of the IMF credit(in current US$) of Grenada in 2002 to that in 2005?
Provide a short and direct response. 0.13. What is the ratio of the IMF credit(in current US$) in India in 2002 to that in 2005?
Your answer should be very brief. 0.95. What is the ratio of the IMF credit(in current US$) of Burundi in 2003 to that in 2004?
Ensure brevity in your answer.  0.79. What is the ratio of the IMF credit(in current US$) in Grenada in 2003 to that in 2004?
Make the answer very short. 0.54. What is the ratio of the IMF credit(in current US$) of India in 2003 to that in 2004?
Make the answer very short. 0.96. What is the ratio of the IMF credit(in current US$) of Burundi in 2003 to that in 2005?
Provide a short and direct response. 0.63. What is the ratio of the IMF credit(in current US$) in Grenada in 2003 to that in 2005?
Make the answer very short. 0.59. What is the ratio of the IMF credit(in current US$) in India in 2003 to that in 2005?
Offer a terse response. 1.04. What is the ratio of the IMF credit(in current US$) in Burundi in 2004 to that in 2005?
Your answer should be compact. 0.8. What is the ratio of the IMF credit(in current US$) of Grenada in 2004 to that in 2005?
Offer a terse response. 1.09. What is the ratio of the IMF credit(in current US$) in India in 2004 to that in 2005?
Your answer should be compact. 1.09. What is the difference between the highest and the second highest IMF credit(in current US$) in Burundi?
Make the answer very short. 1.55e+07. What is the difference between the highest and the second highest IMF credit(in current US$) of Grenada?
Your answer should be very brief. 8.40e+05. What is the difference between the highest and the second highest IMF credit(in current US$) of India?
Offer a terse response. 1.71e+09. What is the difference between the highest and the lowest IMF credit(in current US$) of Burundi?
Offer a terse response. 5.81e+07. What is the difference between the highest and the lowest IMF credit(in current US$) in Grenada?
Keep it short and to the point. 1.05e+07. What is the difference between the highest and the lowest IMF credit(in current US$) of India?
Provide a short and direct response. 1.92e+09. 